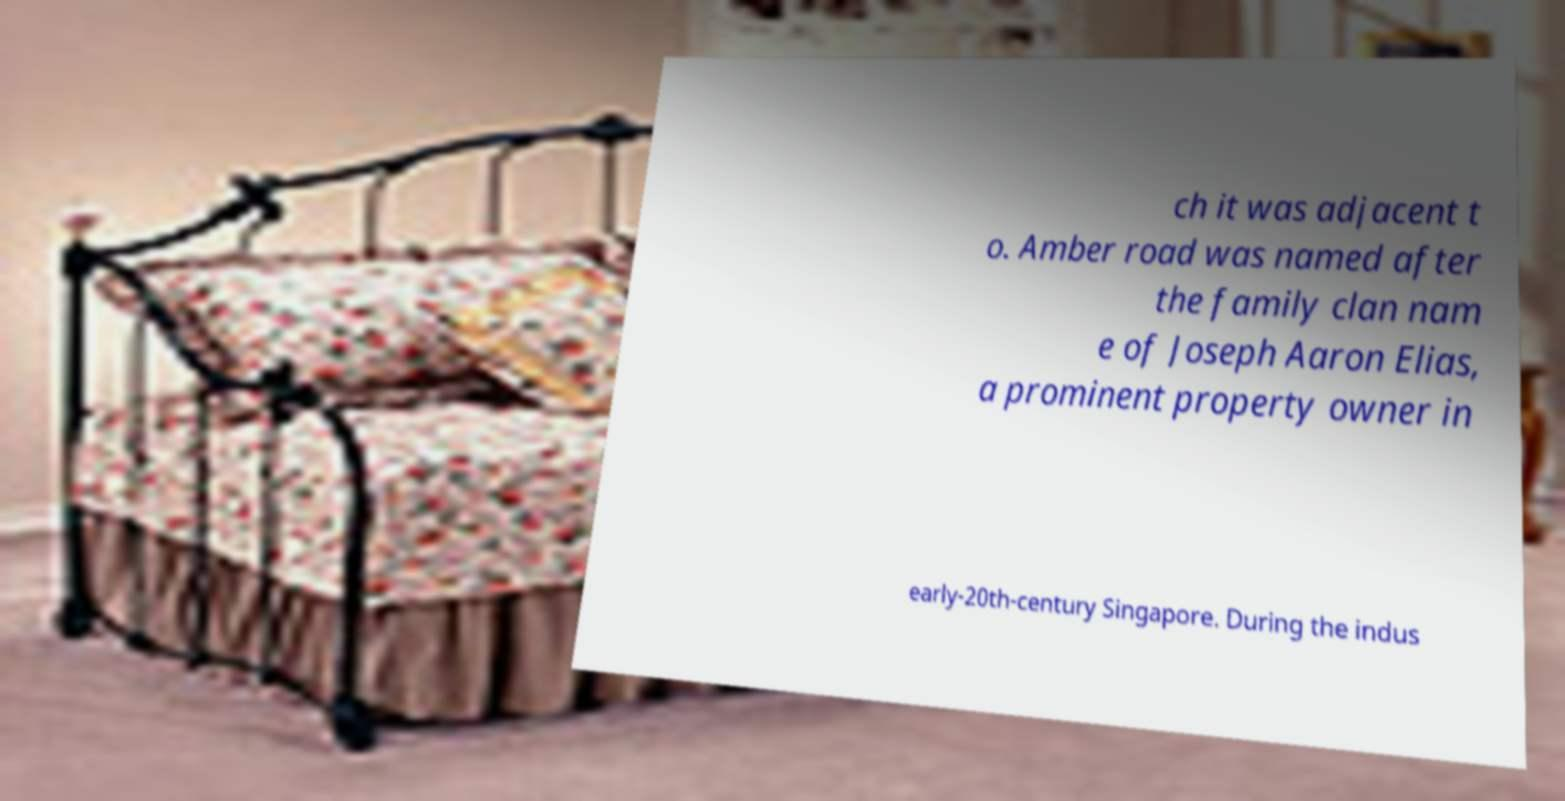Could you extract and type out the text from this image? ch it was adjacent t o. Amber road was named after the family clan nam e of Joseph Aaron Elias, a prominent property owner in early-20th-century Singapore. During the indus 